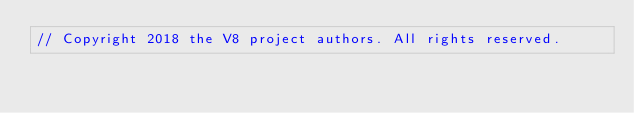<code> <loc_0><loc_0><loc_500><loc_500><_C_>// Copyright 2018 the V8 project authors. All rights reserved.</code> 